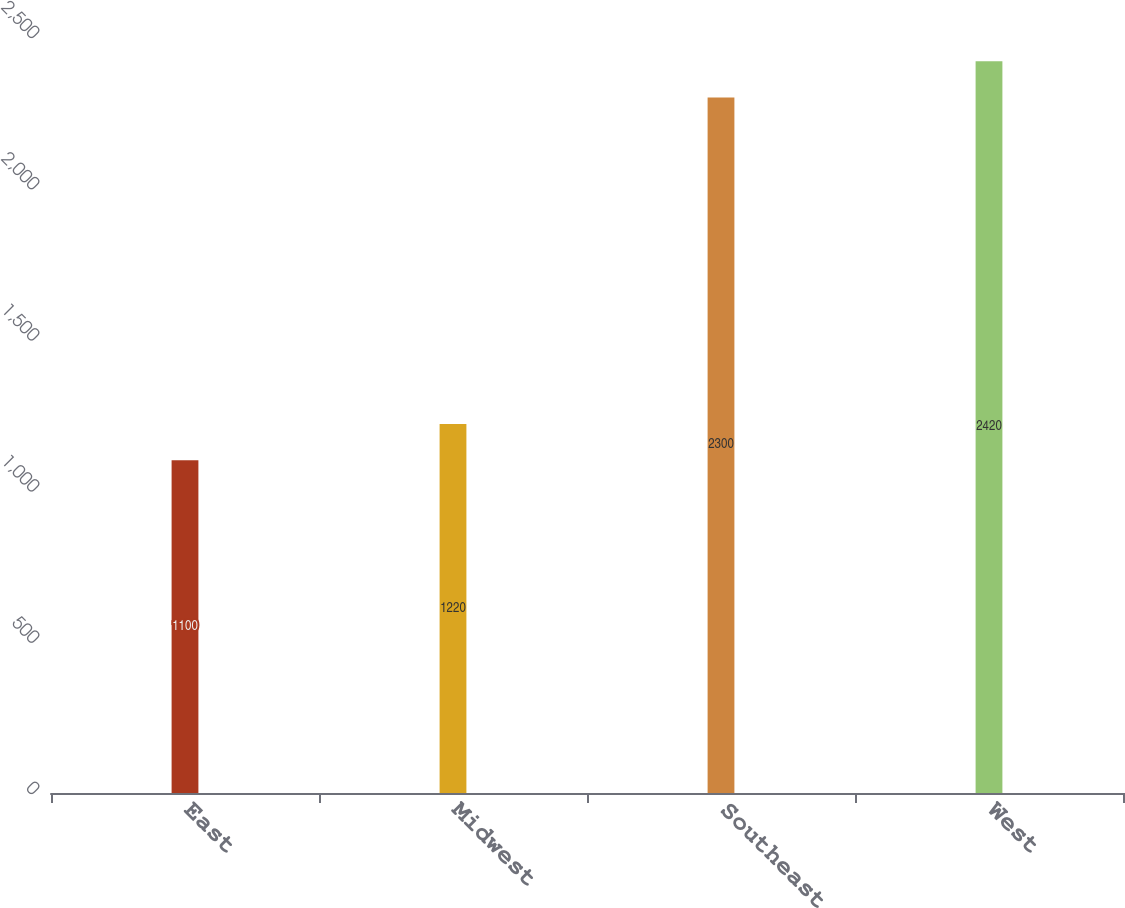Convert chart to OTSL. <chart><loc_0><loc_0><loc_500><loc_500><bar_chart><fcel>East<fcel>Midwest<fcel>Southeast<fcel>West<nl><fcel>1100<fcel>1220<fcel>2300<fcel>2420<nl></chart> 